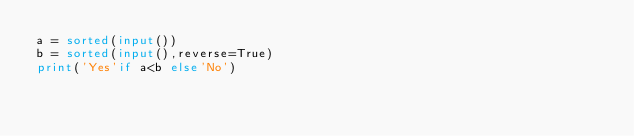Convert code to text. <code><loc_0><loc_0><loc_500><loc_500><_Python_>a = sorted(input())
b = sorted(input(),reverse=True)
print('Yes'if a<b else'No')</code> 